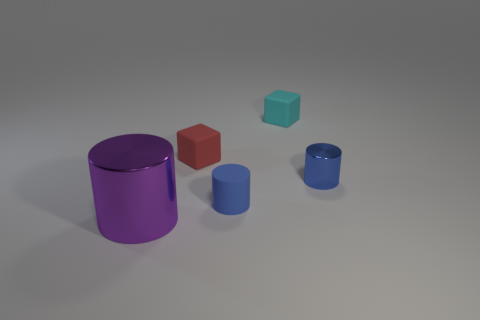There is a tiny rubber thing that is the same color as the tiny shiny thing; what shape is it?
Offer a terse response. Cylinder. What size is the metallic object that is left of the small matte block on the right side of the tiny cylinder that is to the left of the small blue metallic thing?
Your answer should be very brief. Large. There is a red thing that is the same size as the blue shiny thing; what material is it?
Offer a terse response. Rubber. How many other objects are the same material as the cyan cube?
Offer a terse response. 2. There is a shiny thing to the right of the red object; does it have the same color as the small cylinder on the left side of the blue metallic thing?
Keep it short and to the point. Yes. There is a object that is right of the tiny object that is behind the red matte block; what is its shape?
Keep it short and to the point. Cylinder. How many other things are the same color as the big metal thing?
Offer a terse response. 0. Are the cube to the right of the small red thing and the cylinder on the left side of the small red rubber object made of the same material?
Make the answer very short. No. There is a metallic object right of the cyan cube; how big is it?
Give a very brief answer. Small. There is another tiny thing that is the same shape as the tiny red rubber object; what material is it?
Ensure brevity in your answer.  Rubber. 